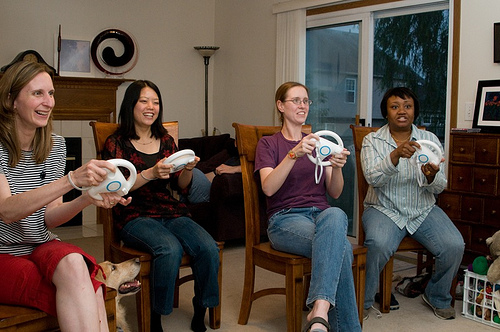<image>What is the man sitting on? There is no man sitting in the image. But if there were, it could be on a chair. What is the man sitting on? I am not sure what the man is sitting on. It can be a chair, or there might not be a man in the image. 